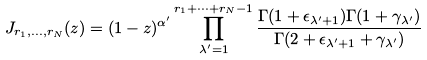<formula> <loc_0><loc_0><loc_500><loc_500>J _ { r _ { 1 } , \dots , r _ { N } } ( z ) = ( 1 - z ) ^ { \alpha ^ { \prime } } \prod _ { \lambda ^ { \prime } = 1 } ^ { r _ { 1 } + \dots + r _ { N } - 1 } \frac { \Gamma ( 1 + \epsilon _ { \lambda ^ { \prime } + 1 } ) \Gamma ( 1 + \gamma _ { \lambda ^ { \prime } } ) } { \Gamma ( 2 + \epsilon _ { \lambda ^ { \prime } + 1 } + \gamma _ { \lambda ^ { \prime } } ) }</formula> 